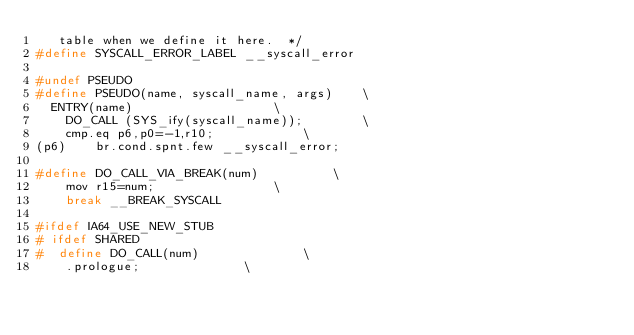Convert code to text. <code><loc_0><loc_0><loc_500><loc_500><_C_>   table when we define it here.  */
#define SYSCALL_ERROR_LABEL __syscall_error

#undef PSEUDO
#define	PSEUDO(name, syscall_name, args)	\
  ENTRY(name)					\
    DO_CALL (SYS_ify(syscall_name));		\
	cmp.eq p6,p0=-1,r10;			\
(p6)	br.cond.spnt.few __syscall_error;

#define DO_CALL_VIA_BREAK(num)			\
	mov r15=num;				\
	break __BREAK_SYSCALL

#ifdef IA64_USE_NEW_STUB
# ifdef SHARED
#  define DO_CALL(num)				\
	.prologue;				\</code> 